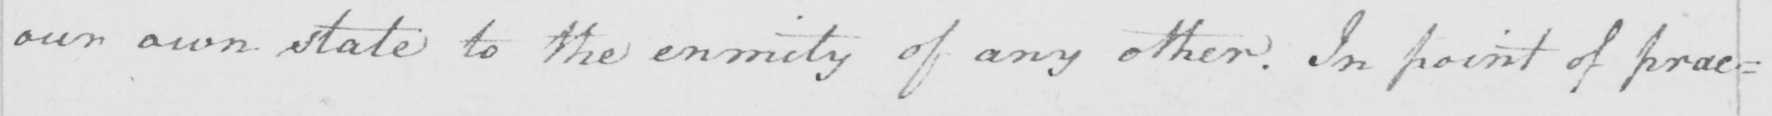Please transcribe the handwritten text in this image. our own state to the enmity of any other . In point of prac= 